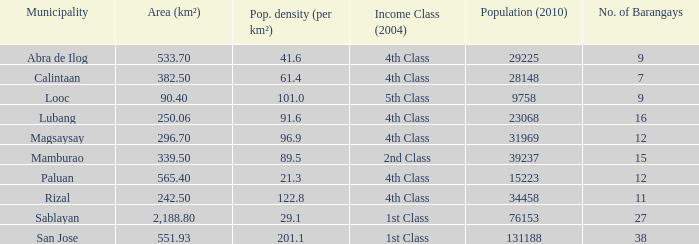What was the smallist population in 2010? 9758.0. 